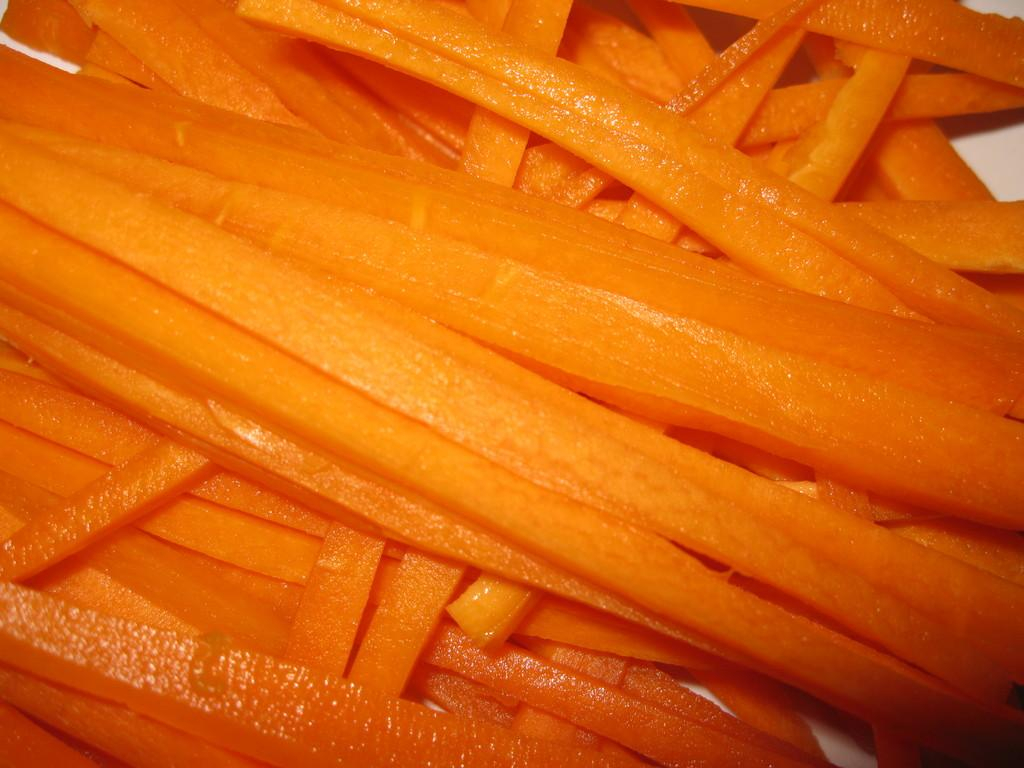What type of food can be seen in the image? There are carrot slices in the image. What is the carrot slices placed on? There is a plate in the image. How many pigs are visible in the image? There are no pigs present in the image. Why are the carrot slices crying in the image? The carrot slices are not crying in the image, as they are inanimate objects and do not have emotions or the ability to cry. 